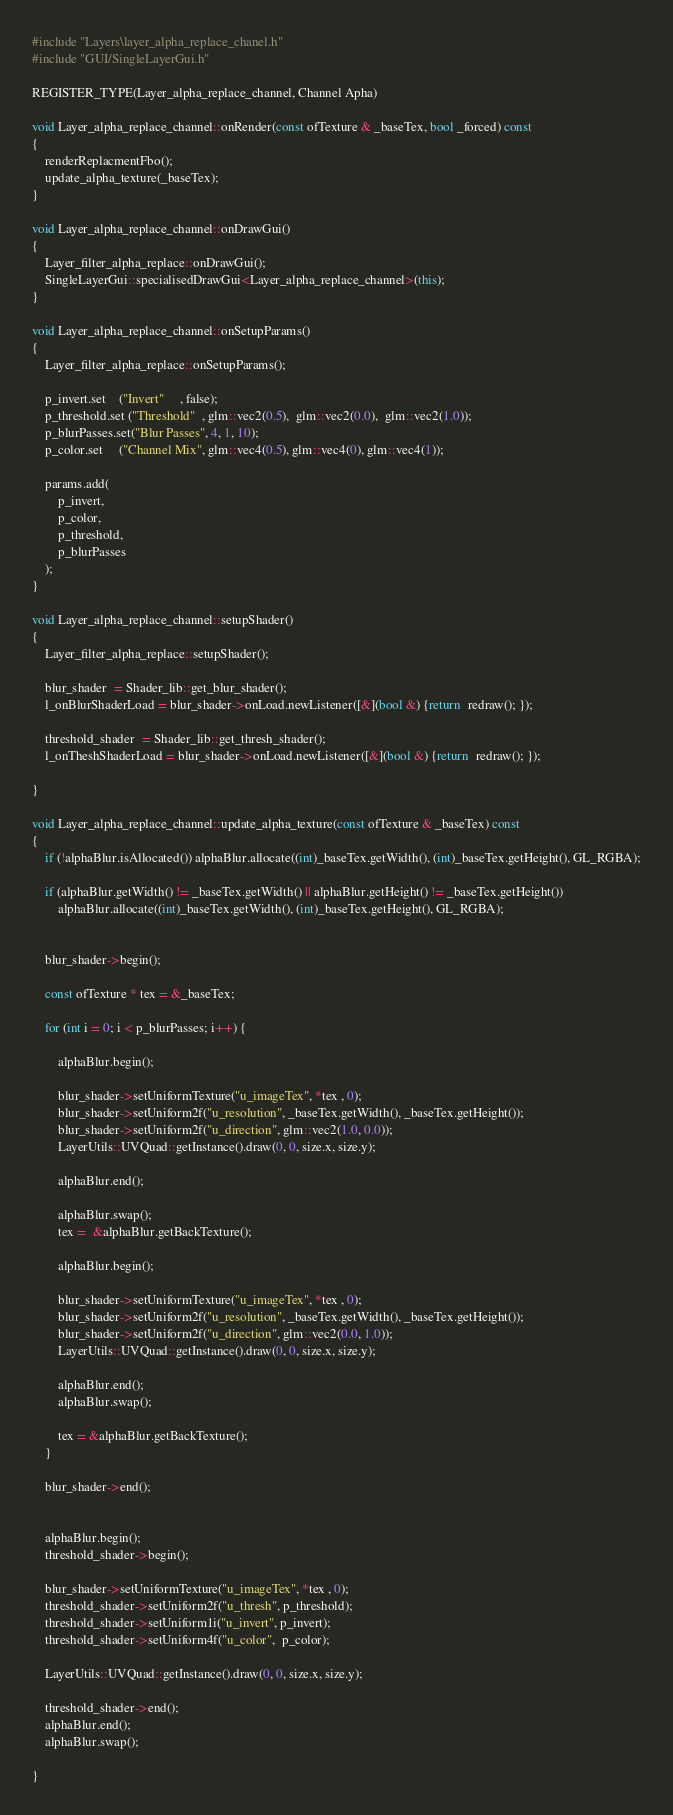Convert code to text. <code><loc_0><loc_0><loc_500><loc_500><_C++_>#include "Layers\layer_alpha_replace_chanel.h"
#include "GUI/SingleLayerGui.h"

REGISTER_TYPE(Layer_alpha_replace_channel, Channel Apha)

void Layer_alpha_replace_channel::onRender(const ofTexture & _baseTex, bool _forced) const
{
    renderReplacmentFbo();
    update_alpha_texture(_baseTex);
}

void Layer_alpha_replace_channel::onDrawGui()
{
    Layer_filter_alpha_replace::onDrawGui();
    SingleLayerGui::specialisedDrawGui<Layer_alpha_replace_channel>(this); 
}

void Layer_alpha_replace_channel::onSetupParams()
{
    Layer_filter_alpha_replace::onSetupParams();

    p_invert.set    ("Invert"     , false);
    p_threshold.set ("Threshold"  , glm::vec2(0.5),  glm::vec2(0.0),  glm::vec2(1.0));
    p_blurPasses.set("Blur Passes", 4, 1, 10);
    p_color.set     ("Channel Mix", glm::vec4(0.5), glm::vec4(0), glm::vec4(1));

    params.add(
        p_invert,
        p_color,
        p_threshold,
        p_blurPasses
    );
}

void Layer_alpha_replace_channel::setupShader()
{
    Layer_filter_alpha_replace::setupShader();

    blur_shader  = Shader_lib::get_blur_shader();
    l_onBlurShaderLoad = blur_shader->onLoad.newListener([&](bool &) {return  redraw(); });

    threshold_shader  = Shader_lib::get_thresh_shader();
    l_onTheshShaderLoad = blur_shader->onLoad.newListener([&](bool &) {return  redraw(); });

}

void Layer_alpha_replace_channel::update_alpha_texture(const ofTexture & _baseTex) const
{
    if (!alphaBlur.isAllocated()) alphaBlur.allocate((int)_baseTex.getWidth(), (int)_baseTex.getHeight(), GL_RGBA);
    
    if (alphaBlur.getWidth() != _baseTex.getWidth() || alphaBlur.getHeight() != _baseTex.getHeight()) 
        alphaBlur.allocate((int)_baseTex.getWidth(), (int)_baseTex.getHeight(), GL_RGBA);


    blur_shader->begin();

    const ofTexture * tex = &_baseTex;

    for (int i = 0; i < p_blurPasses; i++) {

        alphaBlur.begin();

        blur_shader->setUniformTexture("u_imageTex", *tex , 0);
        blur_shader->setUniform2f("u_resolution", _baseTex.getWidth(), _baseTex.getHeight());
        blur_shader->setUniform2f("u_direction", glm::vec2(1.0, 0.0));
        LayerUtils::UVQuad::getInstance().draw(0, 0, size.x, size.y);

        alphaBlur.end();

        alphaBlur.swap();
        tex =  &alphaBlur.getBackTexture();

        alphaBlur.begin();
        
        blur_shader->setUniformTexture("u_imageTex", *tex , 0);
        blur_shader->setUniform2f("u_resolution", _baseTex.getWidth(), _baseTex.getHeight());
        blur_shader->setUniform2f("u_direction", glm::vec2(0.0, 1.0));
        LayerUtils::UVQuad::getInstance().draw(0, 0, size.x, size.y);

        alphaBlur.end();
        alphaBlur.swap();

        tex = &alphaBlur.getBackTexture();
    }

    blur_shader->end();


    alphaBlur.begin();
    threshold_shader->begin();
    
    blur_shader->setUniformTexture("u_imageTex", *tex , 0);
    threshold_shader->setUniform2f("u_thresh", p_threshold);
    threshold_shader->setUniform1i("u_invert", p_invert);
    threshold_shader->setUniform4f("u_color",  p_color);

    LayerUtils::UVQuad::getInstance().draw(0, 0, size.x, size.y);

    threshold_shader->end();
    alphaBlur.end();
    alphaBlur.swap();

}
</code> 